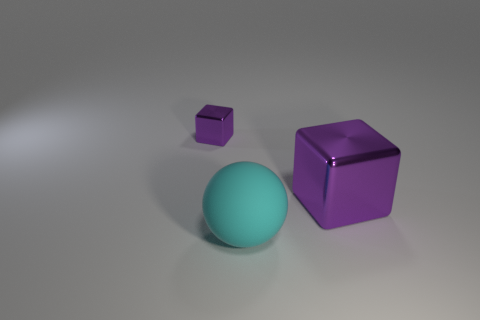Add 2 large purple things. How many objects exist? 5 Subtract 2 blocks. How many blocks are left? 0 Subtract all cubes. How many objects are left? 1 Subtract all cyan rubber spheres. Subtract all big shiny cubes. How many objects are left? 1 Add 3 purple metallic things. How many purple metallic things are left? 5 Add 1 red balls. How many red balls exist? 1 Subtract 0 red balls. How many objects are left? 3 Subtract all brown balls. Subtract all blue cylinders. How many balls are left? 1 